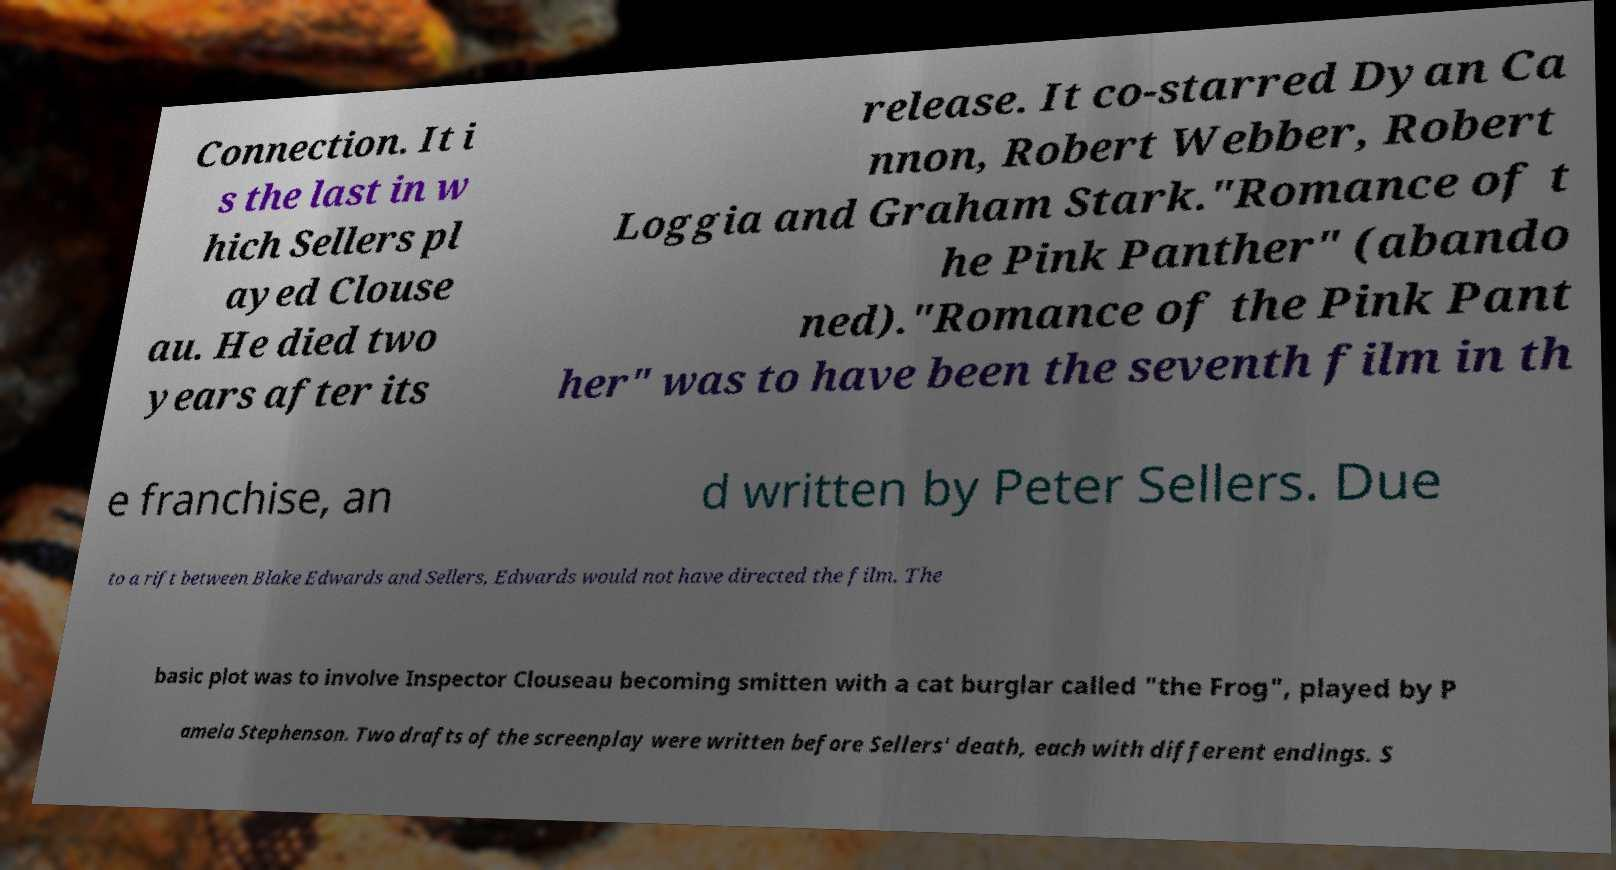Can you read and provide the text displayed in the image?This photo seems to have some interesting text. Can you extract and type it out for me? Connection. It i s the last in w hich Sellers pl ayed Clouse au. He died two years after its release. It co-starred Dyan Ca nnon, Robert Webber, Robert Loggia and Graham Stark."Romance of t he Pink Panther" (abando ned)."Romance of the Pink Pant her" was to have been the seventh film in th e franchise, an d written by Peter Sellers. Due to a rift between Blake Edwards and Sellers, Edwards would not have directed the film. The basic plot was to involve Inspector Clouseau becoming smitten with a cat burglar called "the Frog", played by P amela Stephenson. Two drafts of the screenplay were written before Sellers' death, each with different endings. S 